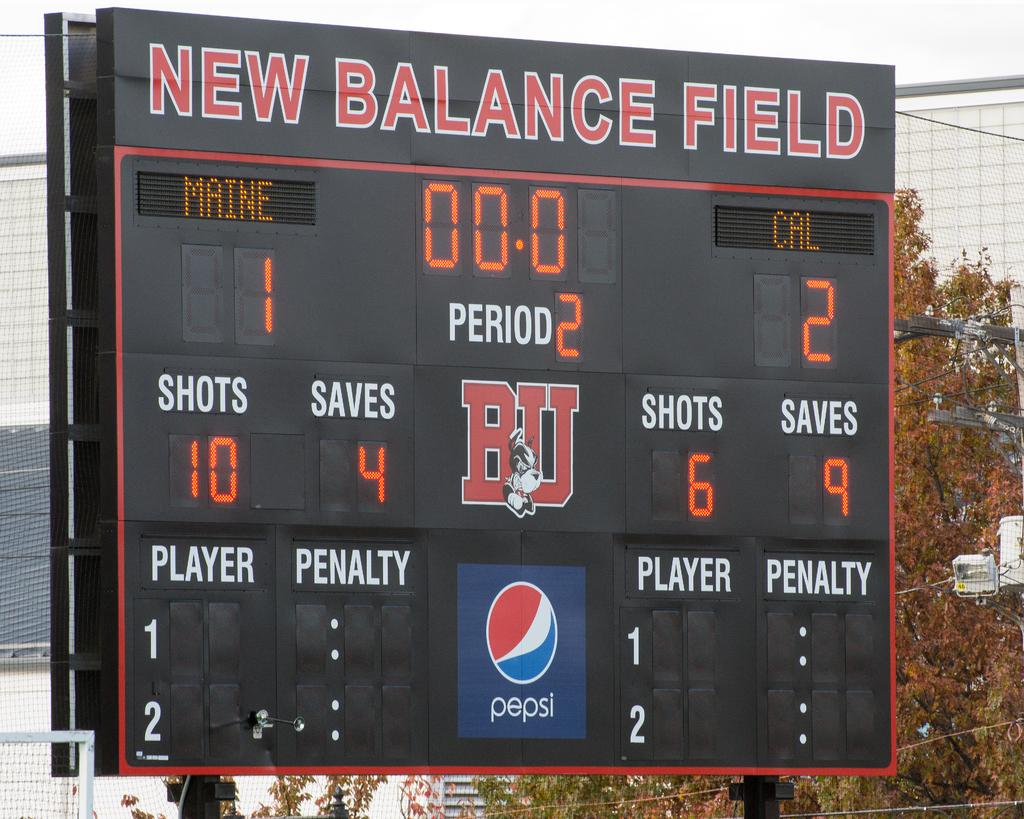What type of display is present in the image? There is a black color LED board in the image. What is shown on the LED board? Something is displayed on the LED board. What can be seen in the background of the image? There are nets, trees, and the sky visible in the background of the image. How does the LED board express regret in the image? The LED board does not express regret in the image; it simply displays something. 